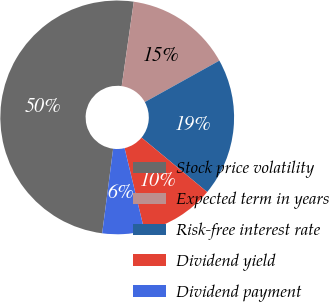Convert chart. <chart><loc_0><loc_0><loc_500><loc_500><pie_chart><fcel>Stock price volatility<fcel>Expected term in years<fcel>Risk-free interest rate<fcel>Dividend yield<fcel>Dividend payment<nl><fcel>50.21%<fcel>14.66%<fcel>19.09%<fcel>10.23%<fcel>5.8%<nl></chart> 